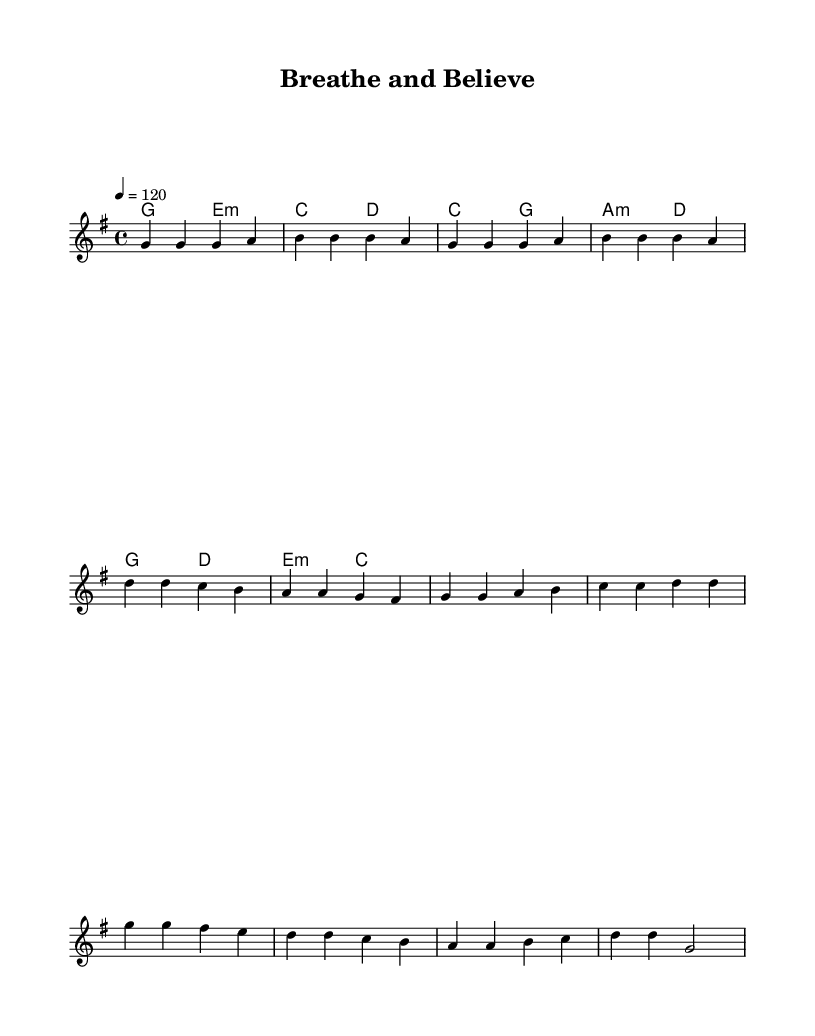What is the key signature of this music? The key signature is G major, which has one sharp (F#).
Answer: G major What is the time signature of this music? The time signature is four beats per measure, indicated as 4/4.
Answer: 4/4 What is the tempo marking for this piece? The tempo marking is 120 beats per minute, commonly marked as “4 = 120”.
Answer: 120 How many bars are in the chorus section? Upon inspection of the sheet music, the chorus section contains four bars, as outlined in the melody notation.
Answer: 4 What chords are used in the pre-chorus? The chords specified in the pre-chorus are C major and A minor, along with D major.
Answer: C major, A minor What is the last note of the melody? The last note of the melody in the score is G in the lower octave, as indicated at the end of the chorus.
Answer: G What is the harmonic structure of the verse? The verse features a harmonic structure of G major and E minor, followed by C major and D major chords.
Answer: G major, E minor 